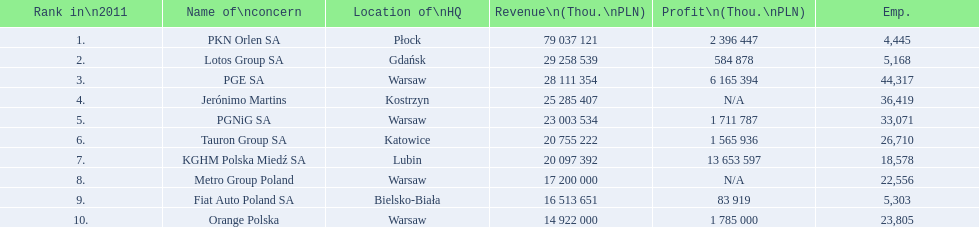What company has 28 111 354 thou.in revenue? PGE SA. What revenue does lotus group sa have? 29 258 539. Who has the next highest revenue than lotus group sa? PKN Orlen SA. 